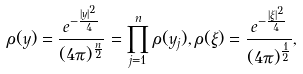Convert formula to latex. <formula><loc_0><loc_0><loc_500><loc_500>\rho ( y ) = \frac { e ^ { - \frac { | y | ^ { 2 } } { 4 } } } { ( 4 \pi ) ^ { \frac { n } { 2 } } } = \prod _ { j = 1 } ^ { n } \rho ( y _ { j } ) , \rho ( \xi ) = \frac { e ^ { - \frac { | \xi | ^ { 2 } } { 4 } } } { ( 4 \pi ) ^ { \frac { 1 } { 2 } } } ,</formula> 